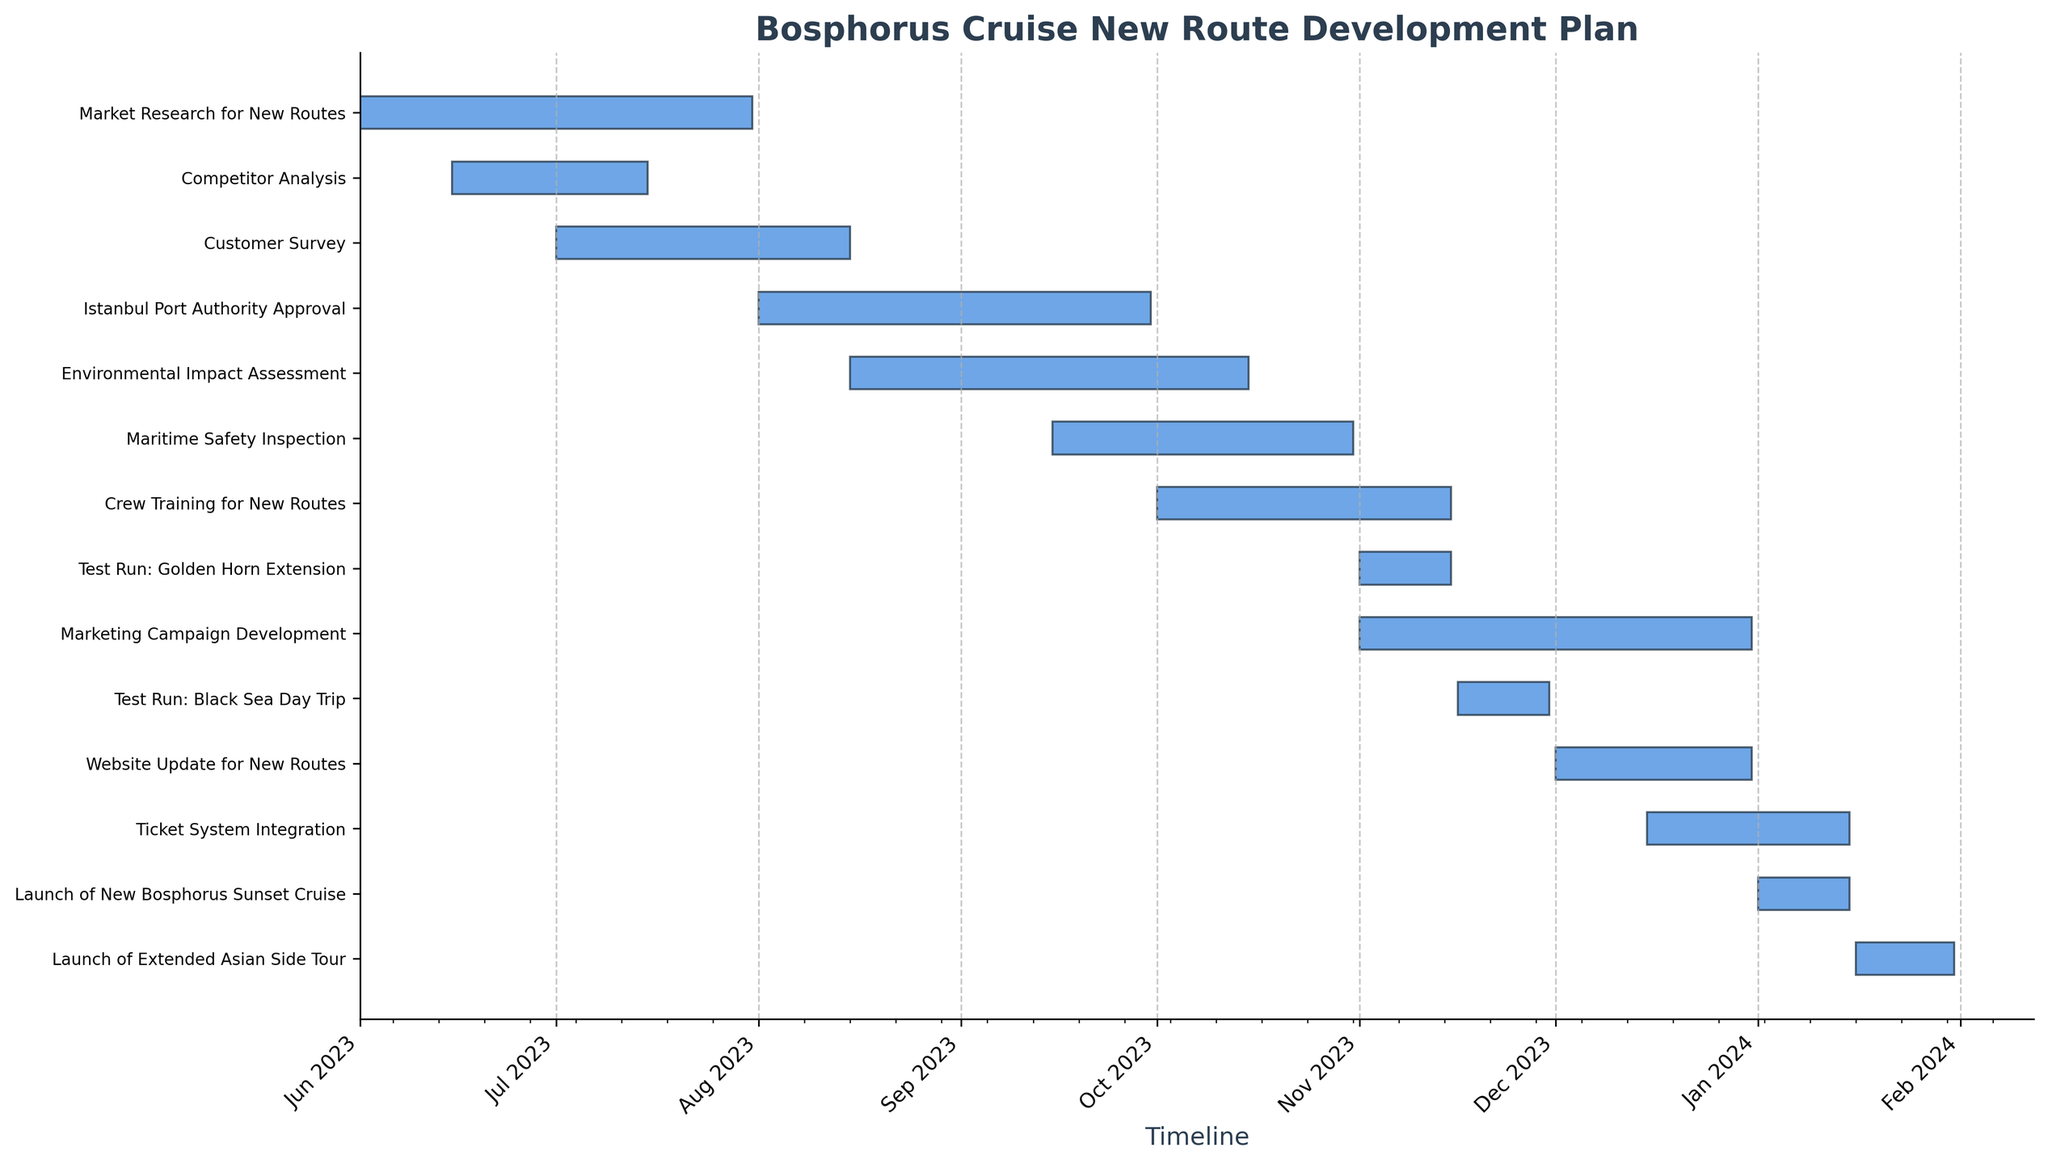What is the title of the chart? The title of the chart is typically located at the top and provides a summary of the content.
Answer: Bosphorus Cruise New Route Development Plan How many phases are listed in the plan? Count the number of horizontal bars, each representing a different task phase.
Answer: 13 What is the start date for the "Customer Survey"? Locate the bar labeled "Customer Survey" and read the start date from its left end.
Answer: 2023-07-01 Which task ends on December 31st, 2023? Identify the task whose horizontal bar ends on December 31st, 2023.
Answer: Marketing Campaign Development and Website Update for New Routes Does the "Market Research for New Routes" phase overlap with the "Competitor Analysis" phase? Check if the horizontal bars for these two tasks overlap on the timeline.
Answer: Yes How long is the "Maritime Safety Inspection" phase? Measure the duration of the bar representing "Maritime Safety Inspection" from start to end dates.
Answer: 46 days What are the tasks scheduled to start in August 2023? Identify all tasks whose horizontal bars begin in August 2023.
Answer: Istanbul Port Authority Approval, Environmental Impact Assessment Which phase has the shortest duration, and how long is it? Measure the duration of each task and identify the shortest one.
Answer: Test Run: Golden Horn Extension, 15 days Compare the duration of "Crew Training for New Routes" and "Test Run: Black Sea Day Trip". Which one is longer? Measure and compare the duration of the bars representing these two tasks.
Answer: Crew Training for New Routes is longer What tasks are planned to start in November 2023? Identify all tasks with start dates in November 2023.
Answer: Test Run: Golden Horn Extension, Marketing Campaign Development 